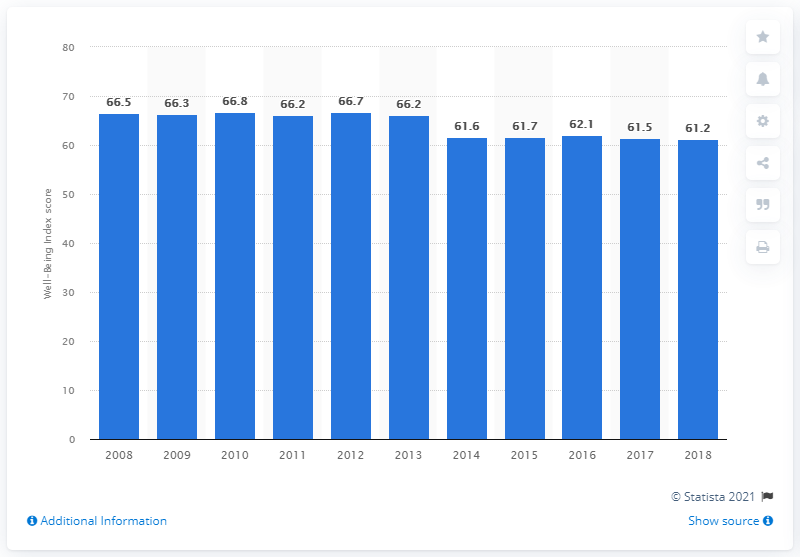Indicate a few pertinent items in this graphic. The nationwide Well-Being Index score of the United States in 2018 was 61.2. 